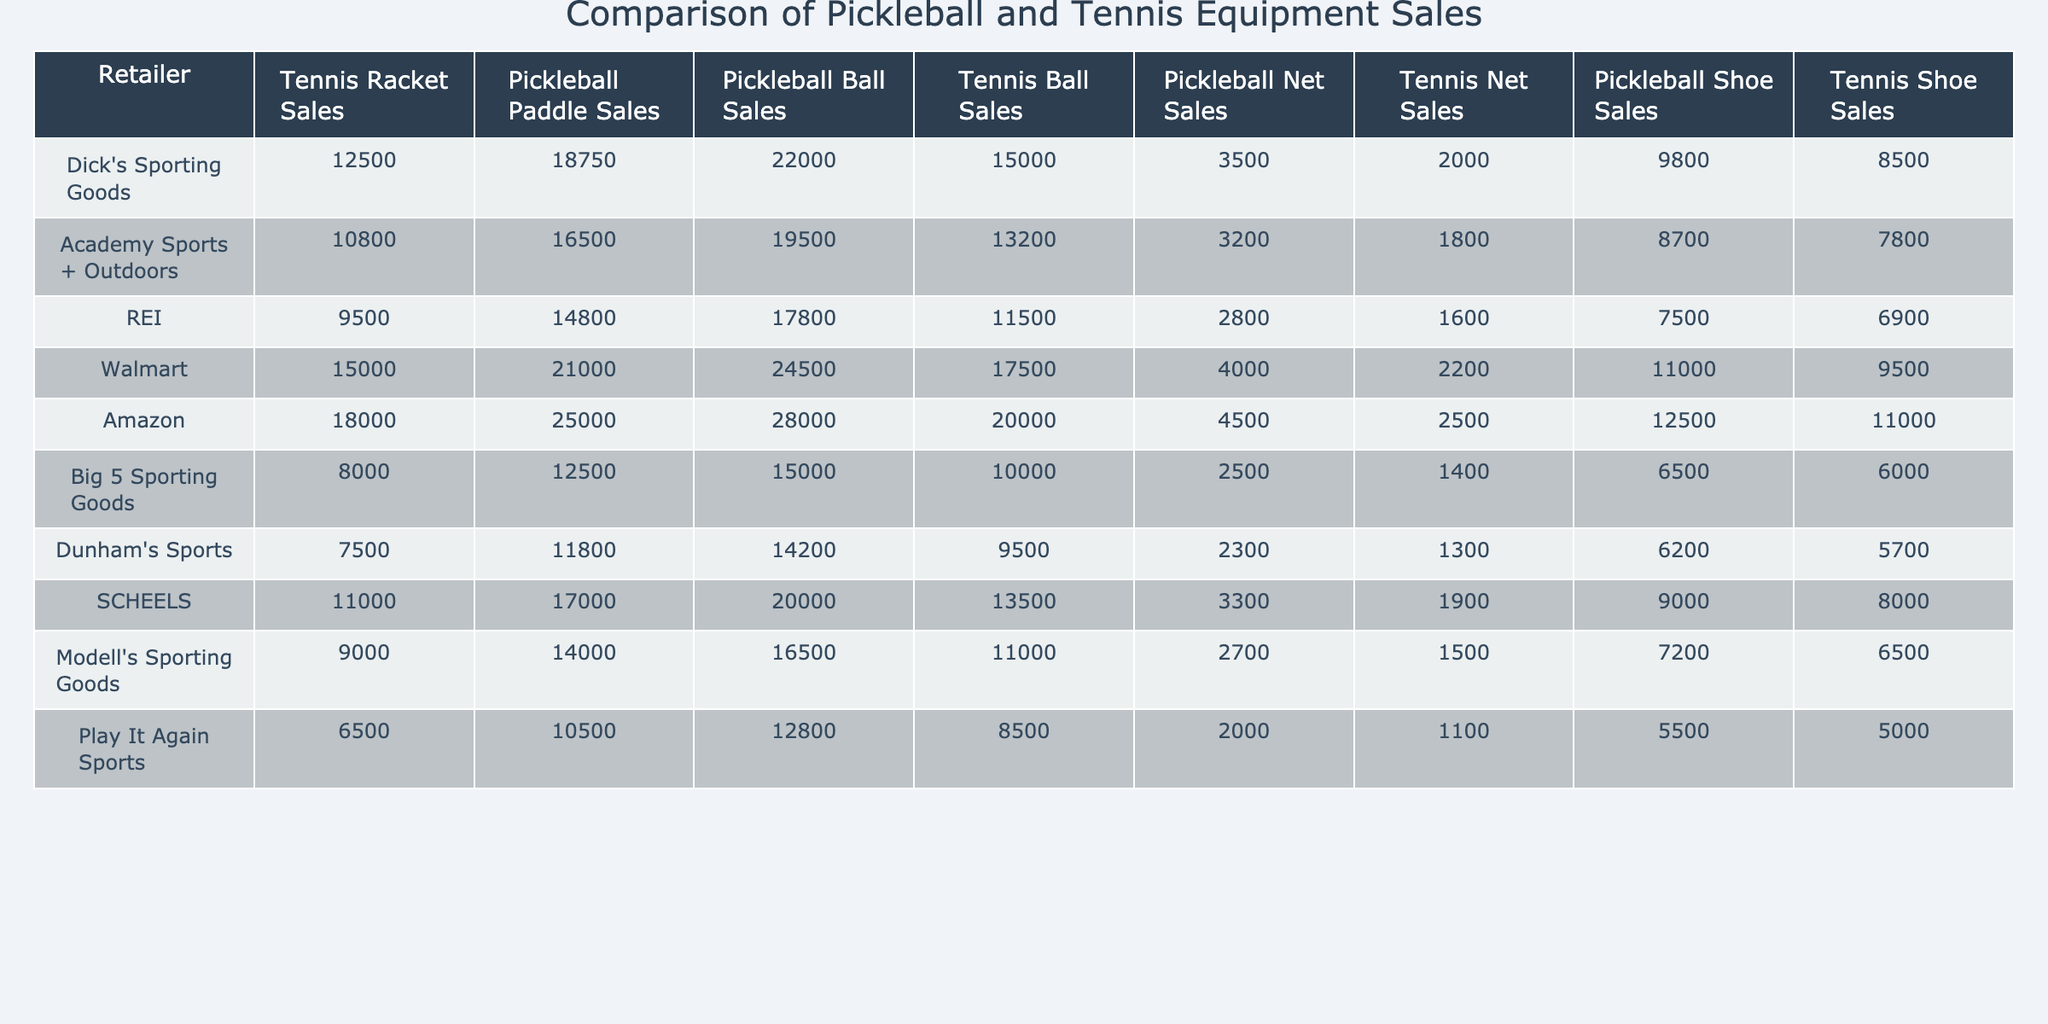What retailer had the highest sales in pickleball paddle sales? By examining the column for Pickleball Paddle Sales and identifying the maximum value, we see that Amazon has the highest sales with 25,000 units.
Answer: Amazon How many pickleball balls did Walmart sell? From the table, Walmart's sales in pickleball balls is directly listed as 24,500.
Answer: 24,500 Which retailer sold more pickleball shoes: Dick's Sporting Goods or Academy Sports + Outdoors? The pickleball shoe sales for Dick's Sporting Goods is 9,800, while Academy Sports + Outdoors sold 8,700. Comparing both numbers, Dick's sold more.
Answer: Dick's Sporting Goods What is the total sales of pickleball equipment (paddles, balls, nets, and shoes) for REI? Adding the respective sales for REI: 14,800 (paddles) + 17,800 (balls) + 2,800 (nets) + 7,500 (shoes) gives us a total of 43,900.
Answer: 43,900 Which retailer has the widest margin between tennis racket sales and pickleball paddle sales? Calculating the differences, we find: Dick's (12,500 - 18,750 = -6,250), Academy (10,800 - 16,500 = -5,700), etc. The largest difference is with Amazon, where (18,000 - 25,000 = -7,000) indicates the widest margin.
Answer: Amazon What is the average sales of pickleball nets across all retailers? First, sum the pickleball net sales: 3,500 + 3,200 + 2,800 + 4,000 + 4,500 + 2,500 + 3,300 + 2,700 + 2,000 = 28,500. Next, divide by the number of retailers (9), which gives the average of 3,166.67.
Answer: 3,166.67 Did any retailer sell more pickleball balls than tennis balls? By checking the respective columns, we see Walmart's pickleball balls sales (24,500) is greater than its tennis ball sales (17,500). Therefore, the answer is yes.
Answer: Yes Which retailer sold the most combined number of pickleball products (paddles, balls, nets, and shoes)? Summing the sales for each retailer reveals that Amazon has the highest combined total: 25,000 (paddles) + 28,000 (balls) + 4,500 (nets) + 12,500 (shoes) = 70,000.
Answer: Amazon Was the sales number for pickleball paddles at Big 5 Sporting Goods above the average sales across all retailers? The average of pickleball paddle sales across all retailers is calculated to be 16,167. Big 5 sold 12,500, which is below the average.
Answer: No How much did Dick’s Sporting Goods sell in total for pickleball-related products? Adding Dick's total for paddles, balls, nets, and shoes: 18,750 + 22,000 + 3,500 + 9,800 = 54,050.
Answer: 54,050 